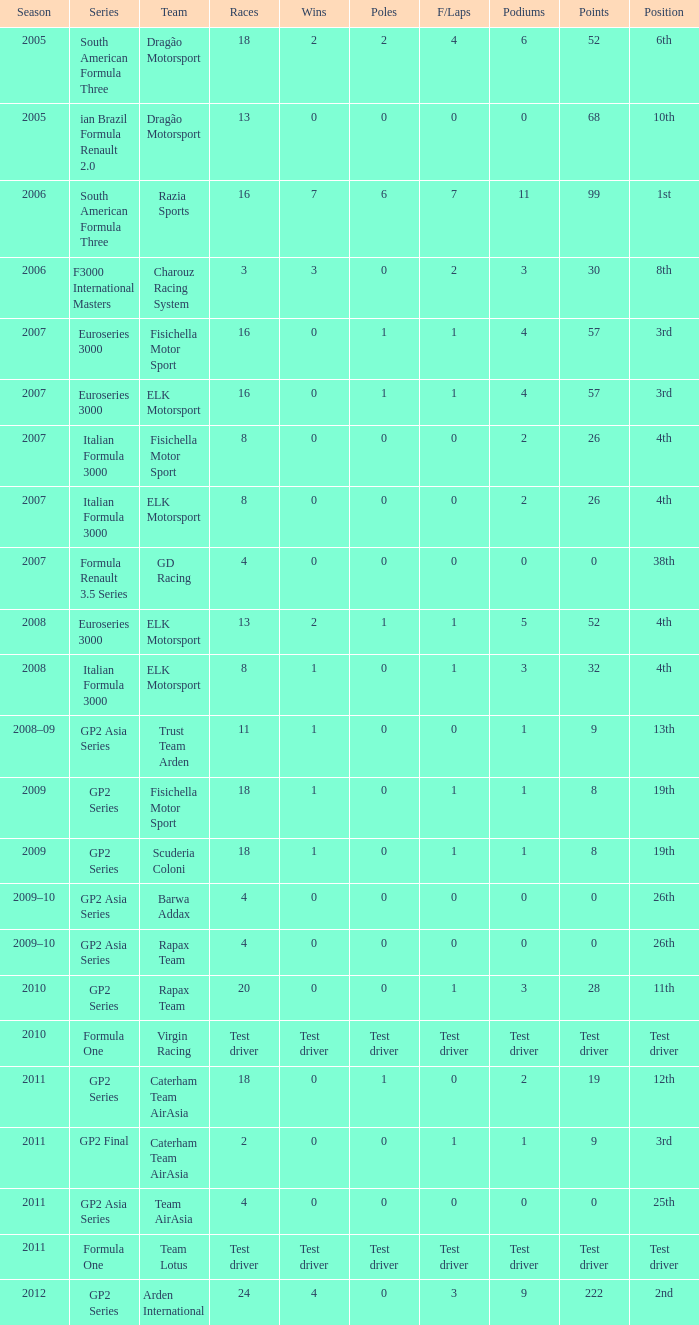When the wins were 0 and the position was 4th, what was the f/laps figure? 0, 0. 